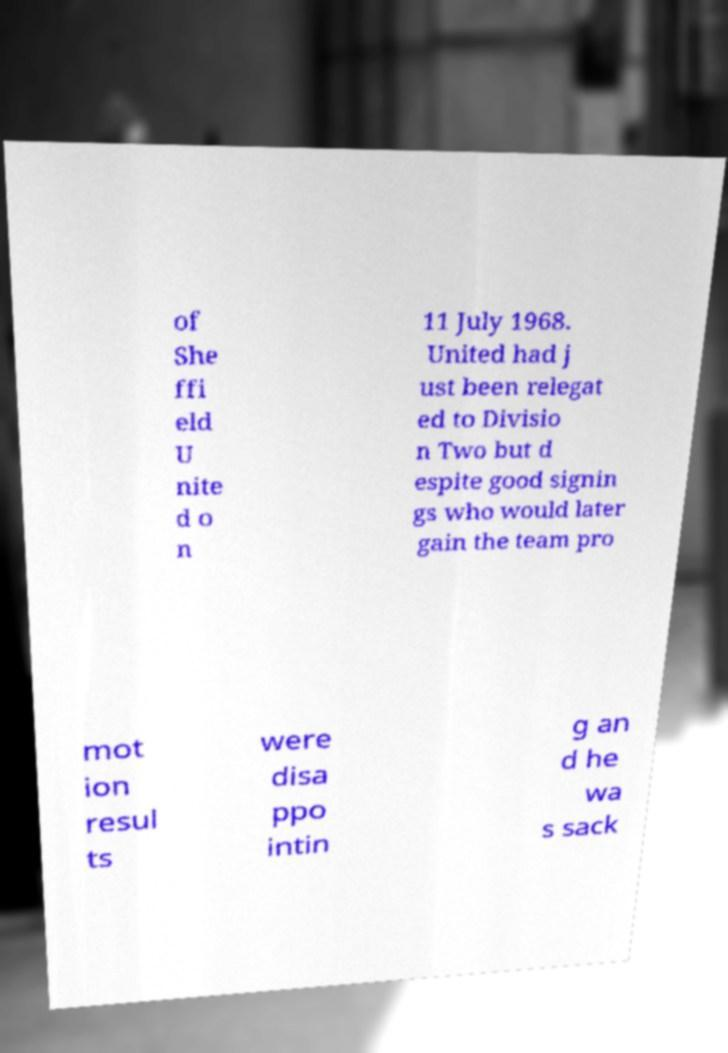Can you accurately transcribe the text from the provided image for me? of She ffi eld U nite d o n 11 July 1968. United had j ust been relegat ed to Divisio n Two but d espite good signin gs who would later gain the team pro mot ion resul ts were disa ppo intin g an d he wa s sack 